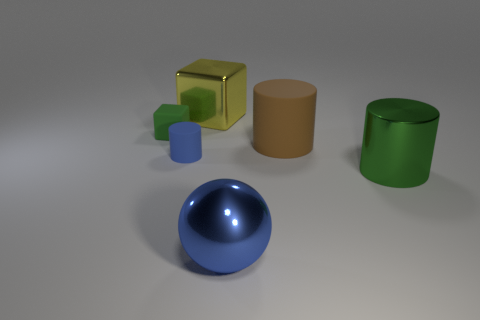Add 1 green cubes. How many objects exist? 7 Subtract all large spheres. Subtract all yellow cubes. How many objects are left? 4 Add 1 large green metal objects. How many large green metal objects are left? 2 Add 3 small metal balls. How many small metal balls exist? 3 Subtract 0 purple cylinders. How many objects are left? 6 Subtract all spheres. How many objects are left? 5 